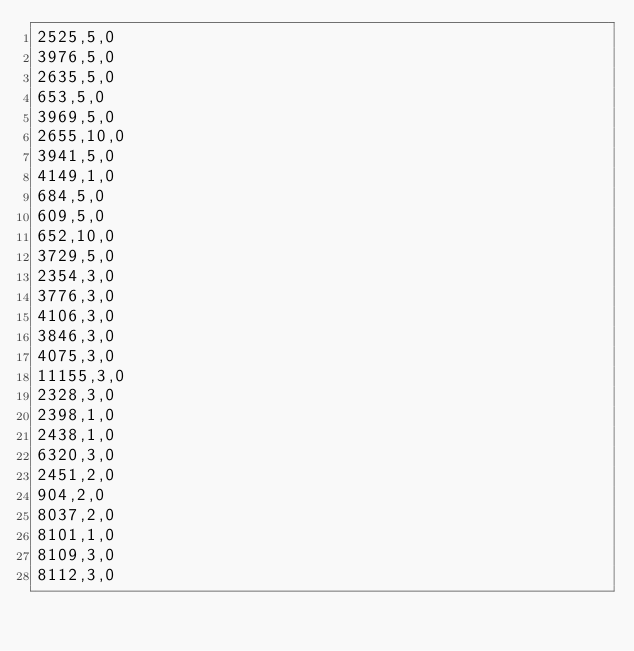Convert code to text. <code><loc_0><loc_0><loc_500><loc_500><_SQL_>2525,5,0
3976,5,0
2635,5,0
653,5,0
3969,5,0
2655,10,0
3941,5,0
4149,1,0
684,5,0
609,5,0
652,10,0
3729,5,0
2354,3,0
3776,3,0
4106,3,0
3846,3,0
4075,3,0
11155,3,0
2328,3,0
2398,1,0
2438,1,0
6320,3,0
2451,2,0
904,2,0
8037,2,0
8101,1,0
8109,3,0
8112,3,0
</code> 